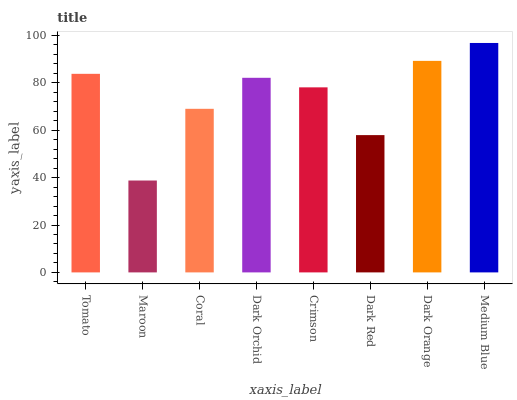Is Maroon the minimum?
Answer yes or no. Yes. Is Medium Blue the maximum?
Answer yes or no. Yes. Is Coral the minimum?
Answer yes or no. No. Is Coral the maximum?
Answer yes or no. No. Is Coral greater than Maroon?
Answer yes or no. Yes. Is Maroon less than Coral?
Answer yes or no. Yes. Is Maroon greater than Coral?
Answer yes or no. No. Is Coral less than Maroon?
Answer yes or no. No. Is Dark Orchid the high median?
Answer yes or no. Yes. Is Crimson the low median?
Answer yes or no. Yes. Is Maroon the high median?
Answer yes or no. No. Is Dark Red the low median?
Answer yes or no. No. 